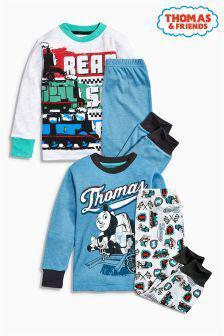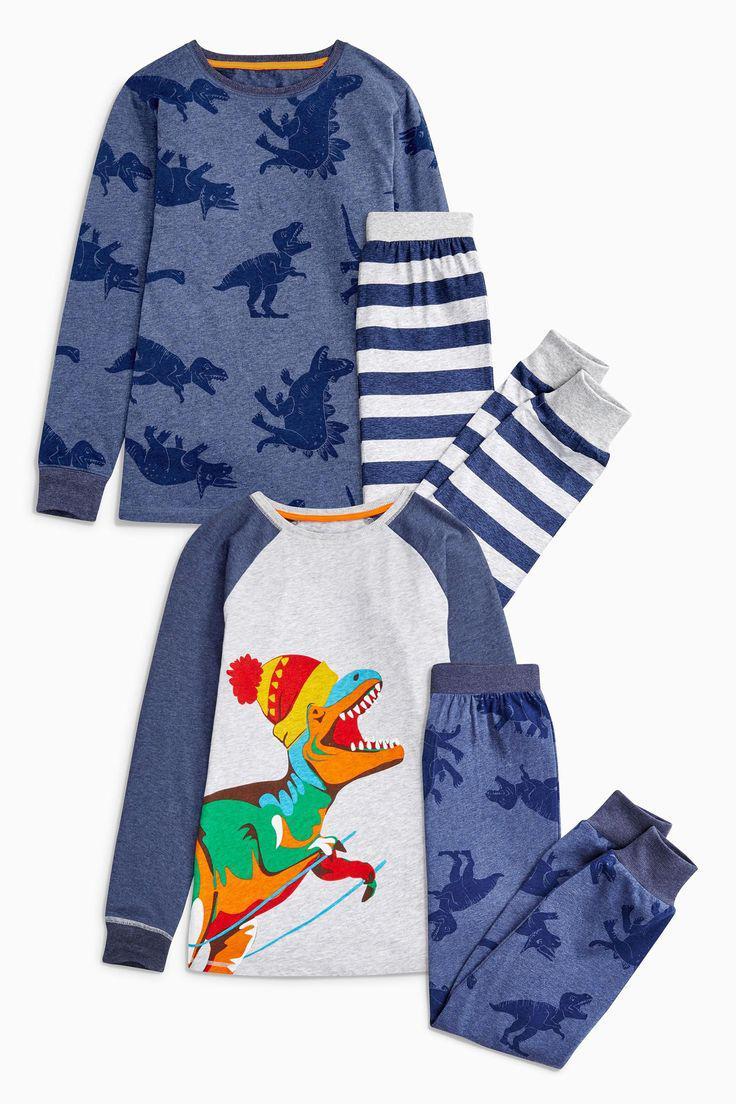The first image is the image on the left, the second image is the image on the right. Examine the images to the left and right. Is the description "No individual image contains more than two sets of sleepwear, and the right image includes a pajama top depicting a cartoon train face." accurate? Answer yes or no. No. The first image is the image on the left, the second image is the image on the right. Considering the images on both sides, is "There are two sets of pajamas in each of the images." valid? Answer yes or no. Yes. 